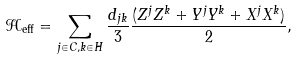Convert formula to latex. <formula><loc_0><loc_0><loc_500><loc_500>\mathcal { H } _ { \text {eff} } = \sum _ { j \in C , k \in H } \frac { d _ { j k } } { 3 } \frac { ( Z ^ { j } Z ^ { k } + Y ^ { j } Y ^ { k } + X ^ { j } X ^ { k } ) } { 2 } ,</formula> 